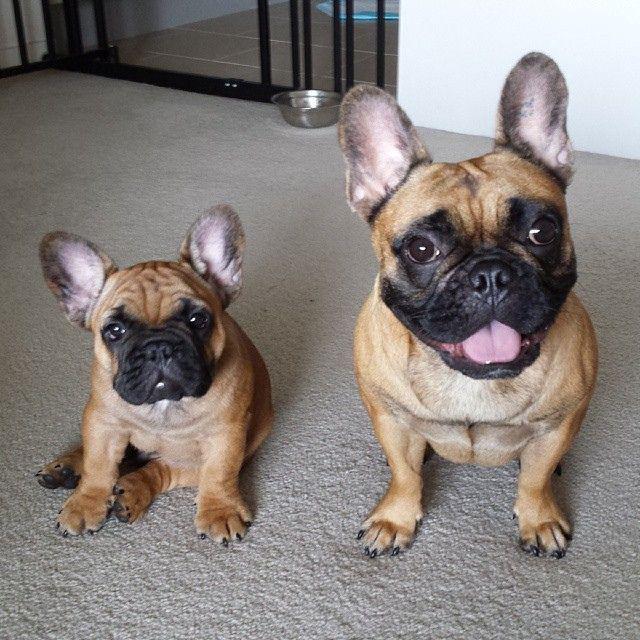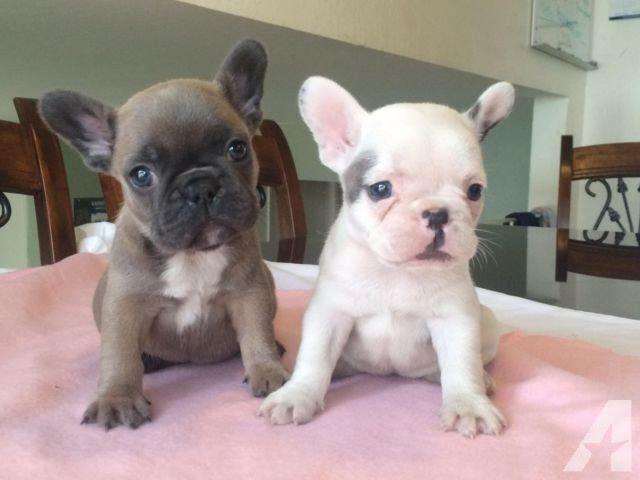The first image is the image on the left, the second image is the image on the right. Given the left and right images, does the statement "In one of the images there are three dogs." hold true? Answer yes or no. No. The first image is the image on the left, the second image is the image on the right. Considering the images on both sides, is "There are exactly three dogs in total." valid? Answer yes or no. No. 